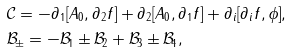Convert formula to latex. <formula><loc_0><loc_0><loc_500><loc_500>& \mathcal { C } = - \partial _ { 1 } [ A _ { 0 } , \partial _ { 2 } f ] + \partial _ { 2 } [ A _ { 0 } , \partial _ { 1 } f ] + \partial _ { i } [ \partial _ { i } f , \phi ] , \\ & \mathcal { B } _ { \pm } = - \mathcal { B } _ { 1 } \pm \mathcal { B } _ { 2 } + \mathcal { B } _ { 3 } \pm \mathcal { B } _ { 4 } ,</formula> 